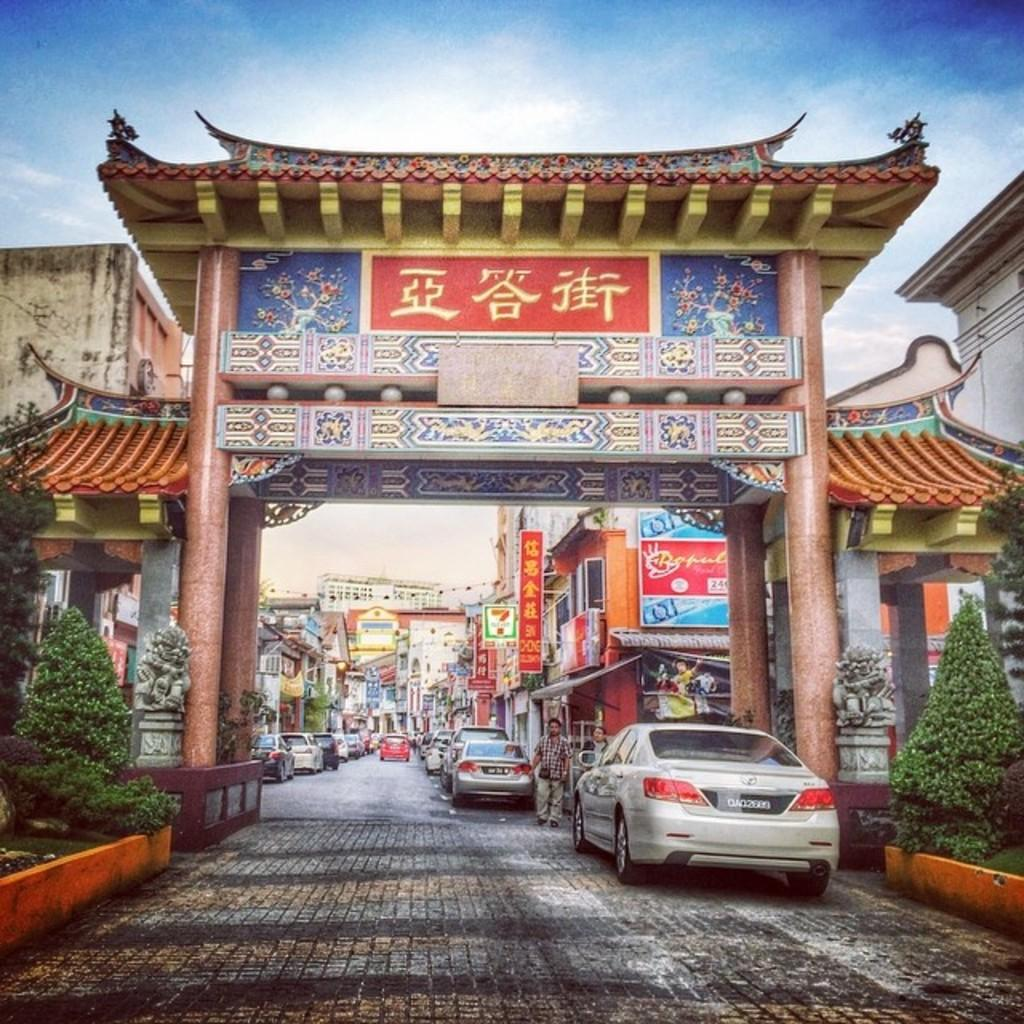What type of natural elements can be seen in the image? There are trees in the image. What else is present in the image besides trees? There are people, vehicles on the road, an arch, hoardings, and buildings in the image. Can you describe the road in the image? The road has vehicles on it. What architectural feature is present in the image? There is an arch in the image. What type of rhythm can be heard from the mouths of the people in the image? There is no indication of any rhythm or sound in the image, and no mouths are visible. 